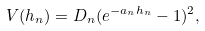Convert formula to latex. <formula><loc_0><loc_0><loc_500><loc_500>V ( h _ { n } ) = D _ { n } ( e ^ { - a _ { n } h _ { n } } - 1 ) ^ { 2 } ,</formula> 